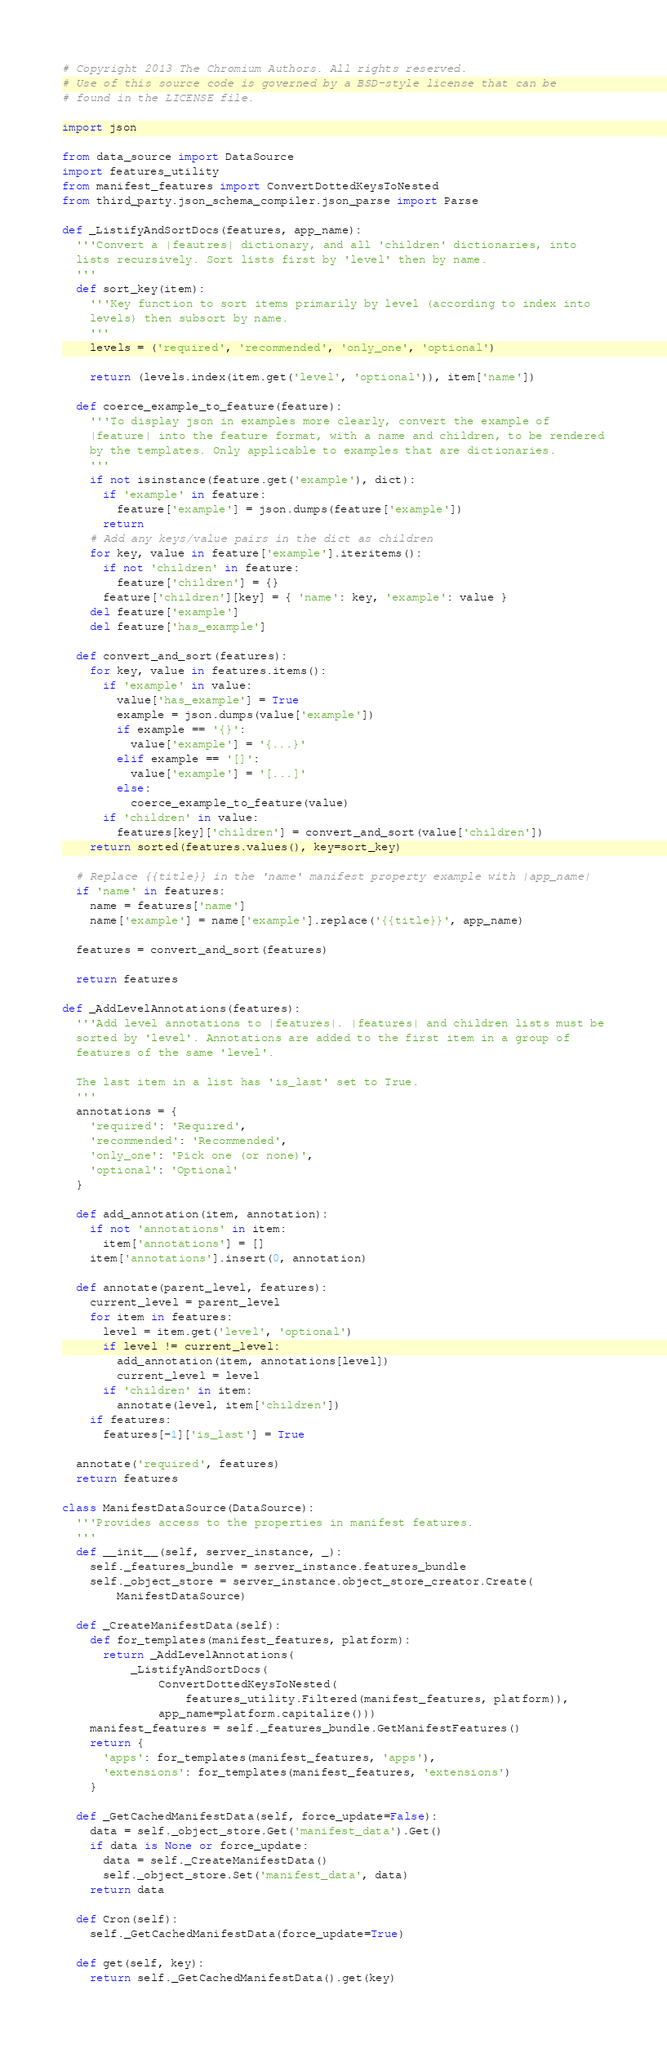<code> <loc_0><loc_0><loc_500><loc_500><_Python_># Copyright 2013 The Chromium Authors. All rights reserved.
# Use of this source code is governed by a BSD-style license that can be
# found in the LICENSE file.

import json

from data_source import DataSource
import features_utility
from manifest_features import ConvertDottedKeysToNested
from third_party.json_schema_compiler.json_parse import Parse

def _ListifyAndSortDocs(features, app_name):
  '''Convert a |feautres| dictionary, and all 'children' dictionaries, into
  lists recursively. Sort lists first by 'level' then by name.
  '''
  def sort_key(item):
    '''Key function to sort items primarily by level (according to index into
    levels) then subsort by name.
    '''
    levels = ('required', 'recommended', 'only_one', 'optional')

    return (levels.index(item.get('level', 'optional')), item['name'])

  def coerce_example_to_feature(feature):
    '''To display json in examples more clearly, convert the example of
    |feature| into the feature format, with a name and children, to be rendered
    by the templates. Only applicable to examples that are dictionaries.
    '''
    if not isinstance(feature.get('example'), dict):
      if 'example' in feature:
        feature['example'] = json.dumps(feature['example'])
      return
    # Add any keys/value pairs in the dict as children
    for key, value in feature['example'].iteritems():
      if not 'children' in feature:
        feature['children'] = {}
      feature['children'][key] = { 'name': key, 'example': value }
    del feature['example']
    del feature['has_example']

  def convert_and_sort(features):
    for key, value in features.items():
      if 'example' in value:
        value['has_example'] = True
        example = json.dumps(value['example'])
        if example == '{}':
          value['example'] = '{...}'
        elif example == '[]':
          value['example'] = '[...]'
        else:
          coerce_example_to_feature(value)
      if 'children' in value:
        features[key]['children'] = convert_and_sort(value['children'])
    return sorted(features.values(), key=sort_key)

  # Replace {{title}} in the 'name' manifest property example with |app_name|
  if 'name' in features:
    name = features['name']
    name['example'] = name['example'].replace('{{title}}', app_name)

  features = convert_and_sort(features)

  return features

def _AddLevelAnnotations(features):
  '''Add level annotations to |features|. |features| and children lists must be
  sorted by 'level'. Annotations are added to the first item in a group of
  features of the same 'level'.

  The last item in a list has 'is_last' set to True.
  '''
  annotations = {
    'required': 'Required',
    'recommended': 'Recommended',
    'only_one': 'Pick one (or none)',
    'optional': 'Optional'
  }

  def add_annotation(item, annotation):
    if not 'annotations' in item:
      item['annotations'] = []
    item['annotations'].insert(0, annotation)

  def annotate(parent_level, features):
    current_level = parent_level
    for item in features:
      level = item.get('level', 'optional')
      if level != current_level:
        add_annotation(item, annotations[level])
        current_level = level
      if 'children' in item:
        annotate(level, item['children'])
    if features:
      features[-1]['is_last'] = True

  annotate('required', features)
  return features

class ManifestDataSource(DataSource):
  '''Provides access to the properties in manifest features.
  '''
  def __init__(self, server_instance, _):
    self._features_bundle = server_instance.features_bundle
    self._object_store = server_instance.object_store_creator.Create(
        ManifestDataSource)

  def _CreateManifestData(self):
    def for_templates(manifest_features, platform):
      return _AddLevelAnnotations(
          _ListifyAndSortDocs(
              ConvertDottedKeysToNested(
                  features_utility.Filtered(manifest_features, platform)),
              app_name=platform.capitalize()))
    manifest_features = self._features_bundle.GetManifestFeatures()
    return {
      'apps': for_templates(manifest_features, 'apps'),
      'extensions': for_templates(manifest_features, 'extensions')
    }

  def _GetCachedManifestData(self, force_update=False):
    data = self._object_store.Get('manifest_data').Get()
    if data is None or force_update:
      data = self._CreateManifestData()
      self._object_store.Set('manifest_data', data)
    return data

  def Cron(self):
    self._GetCachedManifestData(force_update=True)

  def get(self, key):
    return self._GetCachedManifestData().get(key)
</code> 